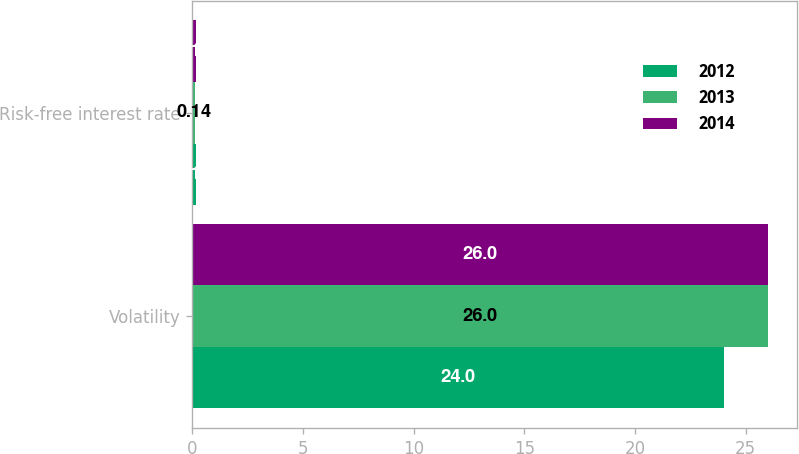Convert chart. <chart><loc_0><loc_0><loc_500><loc_500><stacked_bar_chart><ecel><fcel>Volatility<fcel>Risk-free interest rate<nl><fcel>2012<fcel>24<fcel>0.16<nl><fcel>2013<fcel>26<fcel>0.14<nl><fcel>2014<fcel>26<fcel>0.16<nl></chart> 